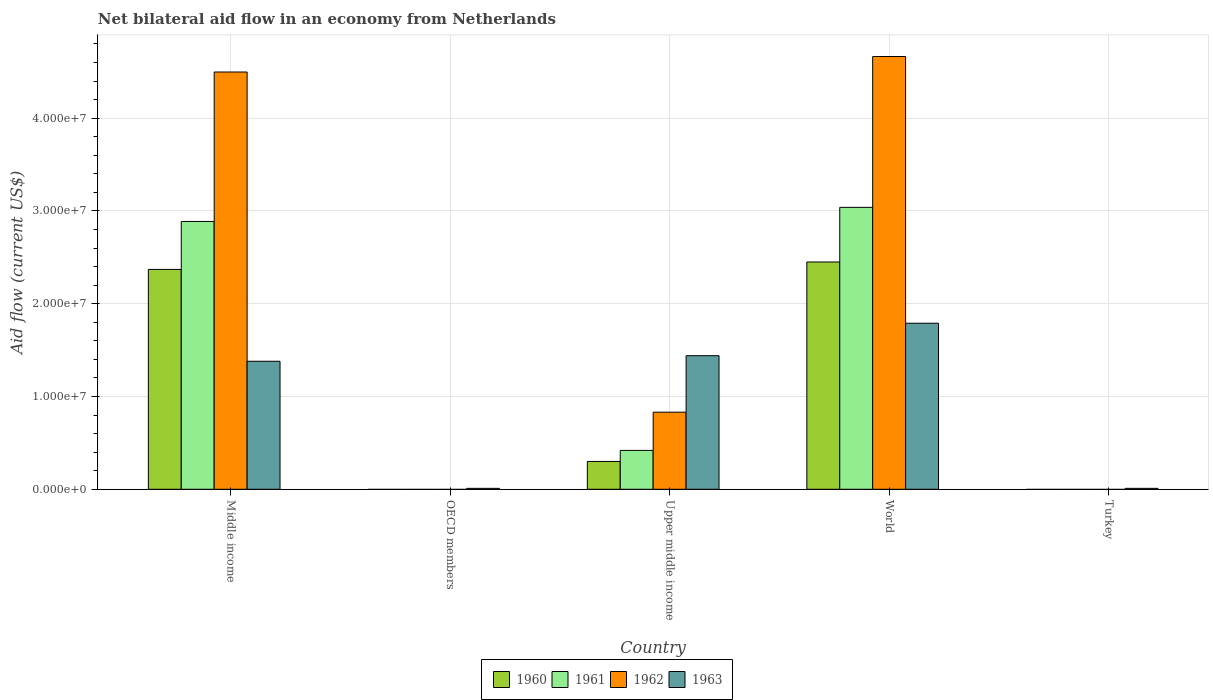Are the number of bars per tick equal to the number of legend labels?
Offer a terse response. No. Are the number of bars on each tick of the X-axis equal?
Ensure brevity in your answer.  No. How many bars are there on the 2nd tick from the left?
Keep it short and to the point. 1. In how many cases, is the number of bars for a given country not equal to the number of legend labels?
Your answer should be compact. 2. Across all countries, what is the maximum net bilateral aid flow in 1963?
Keep it short and to the point. 1.79e+07. Across all countries, what is the minimum net bilateral aid flow in 1963?
Offer a very short reply. 1.00e+05. What is the total net bilateral aid flow in 1962 in the graph?
Give a very brief answer. 9.99e+07. What is the difference between the net bilateral aid flow in 1963 in OECD members and that in Upper middle income?
Keep it short and to the point. -1.43e+07. What is the difference between the net bilateral aid flow in 1962 in Upper middle income and the net bilateral aid flow in 1961 in Turkey?
Offer a terse response. 8.31e+06. What is the average net bilateral aid flow in 1962 per country?
Keep it short and to the point. 2.00e+07. What is the difference between the net bilateral aid flow of/in 1960 and net bilateral aid flow of/in 1961 in Upper middle income?
Provide a succinct answer. -1.19e+06. What is the ratio of the net bilateral aid flow in 1960 in Middle income to that in Upper middle income?
Your answer should be very brief. 7.9. Is the net bilateral aid flow in 1963 in Upper middle income less than that in World?
Keep it short and to the point. Yes. What is the difference between the highest and the second highest net bilateral aid flow in 1962?
Your answer should be very brief. 1.67e+06. What is the difference between the highest and the lowest net bilateral aid flow in 1963?
Make the answer very short. 1.78e+07. In how many countries, is the net bilateral aid flow in 1961 greater than the average net bilateral aid flow in 1961 taken over all countries?
Give a very brief answer. 2. Is the sum of the net bilateral aid flow in 1960 in Middle income and World greater than the maximum net bilateral aid flow in 1963 across all countries?
Give a very brief answer. Yes. Is it the case that in every country, the sum of the net bilateral aid flow in 1960 and net bilateral aid flow in 1962 is greater than the sum of net bilateral aid flow in 1961 and net bilateral aid flow in 1963?
Ensure brevity in your answer.  No. Is it the case that in every country, the sum of the net bilateral aid flow in 1962 and net bilateral aid flow in 1963 is greater than the net bilateral aid flow in 1961?
Your response must be concise. Yes. How many bars are there?
Keep it short and to the point. 14. Are all the bars in the graph horizontal?
Your answer should be very brief. No. Does the graph contain any zero values?
Keep it short and to the point. Yes. Where does the legend appear in the graph?
Make the answer very short. Bottom center. How are the legend labels stacked?
Provide a succinct answer. Horizontal. What is the title of the graph?
Make the answer very short. Net bilateral aid flow in an economy from Netherlands. Does "1987" appear as one of the legend labels in the graph?
Provide a short and direct response. No. What is the label or title of the X-axis?
Offer a very short reply. Country. What is the label or title of the Y-axis?
Your response must be concise. Aid flow (current US$). What is the Aid flow (current US$) of 1960 in Middle income?
Your answer should be compact. 2.37e+07. What is the Aid flow (current US$) of 1961 in Middle income?
Make the answer very short. 2.89e+07. What is the Aid flow (current US$) of 1962 in Middle income?
Provide a short and direct response. 4.50e+07. What is the Aid flow (current US$) in 1963 in Middle income?
Your answer should be compact. 1.38e+07. What is the Aid flow (current US$) in 1960 in OECD members?
Ensure brevity in your answer.  0. What is the Aid flow (current US$) of 1961 in OECD members?
Provide a succinct answer. 0. What is the Aid flow (current US$) of 1961 in Upper middle income?
Your answer should be very brief. 4.19e+06. What is the Aid flow (current US$) of 1962 in Upper middle income?
Offer a terse response. 8.31e+06. What is the Aid flow (current US$) in 1963 in Upper middle income?
Ensure brevity in your answer.  1.44e+07. What is the Aid flow (current US$) of 1960 in World?
Make the answer very short. 2.45e+07. What is the Aid flow (current US$) in 1961 in World?
Your answer should be compact. 3.04e+07. What is the Aid flow (current US$) of 1962 in World?
Your answer should be compact. 4.66e+07. What is the Aid flow (current US$) in 1963 in World?
Your response must be concise. 1.79e+07. What is the Aid flow (current US$) in 1961 in Turkey?
Your response must be concise. 0. Across all countries, what is the maximum Aid flow (current US$) of 1960?
Keep it short and to the point. 2.45e+07. Across all countries, what is the maximum Aid flow (current US$) in 1961?
Give a very brief answer. 3.04e+07. Across all countries, what is the maximum Aid flow (current US$) of 1962?
Your answer should be compact. 4.66e+07. Across all countries, what is the maximum Aid flow (current US$) in 1963?
Keep it short and to the point. 1.79e+07. Across all countries, what is the minimum Aid flow (current US$) of 1960?
Provide a succinct answer. 0. Across all countries, what is the minimum Aid flow (current US$) of 1963?
Make the answer very short. 1.00e+05. What is the total Aid flow (current US$) in 1960 in the graph?
Give a very brief answer. 5.12e+07. What is the total Aid flow (current US$) of 1961 in the graph?
Give a very brief answer. 6.34e+07. What is the total Aid flow (current US$) of 1962 in the graph?
Keep it short and to the point. 9.99e+07. What is the total Aid flow (current US$) of 1963 in the graph?
Your response must be concise. 4.63e+07. What is the difference between the Aid flow (current US$) of 1963 in Middle income and that in OECD members?
Your answer should be very brief. 1.37e+07. What is the difference between the Aid flow (current US$) in 1960 in Middle income and that in Upper middle income?
Keep it short and to the point. 2.07e+07. What is the difference between the Aid flow (current US$) of 1961 in Middle income and that in Upper middle income?
Provide a succinct answer. 2.47e+07. What is the difference between the Aid flow (current US$) in 1962 in Middle income and that in Upper middle income?
Your answer should be compact. 3.67e+07. What is the difference between the Aid flow (current US$) of 1963 in Middle income and that in Upper middle income?
Provide a succinct answer. -6.00e+05. What is the difference between the Aid flow (current US$) of 1960 in Middle income and that in World?
Give a very brief answer. -8.00e+05. What is the difference between the Aid flow (current US$) in 1961 in Middle income and that in World?
Your answer should be compact. -1.52e+06. What is the difference between the Aid flow (current US$) in 1962 in Middle income and that in World?
Provide a short and direct response. -1.67e+06. What is the difference between the Aid flow (current US$) of 1963 in Middle income and that in World?
Your response must be concise. -4.10e+06. What is the difference between the Aid flow (current US$) in 1963 in Middle income and that in Turkey?
Ensure brevity in your answer.  1.37e+07. What is the difference between the Aid flow (current US$) of 1963 in OECD members and that in Upper middle income?
Your answer should be very brief. -1.43e+07. What is the difference between the Aid flow (current US$) in 1963 in OECD members and that in World?
Make the answer very short. -1.78e+07. What is the difference between the Aid flow (current US$) in 1960 in Upper middle income and that in World?
Offer a terse response. -2.15e+07. What is the difference between the Aid flow (current US$) in 1961 in Upper middle income and that in World?
Offer a very short reply. -2.62e+07. What is the difference between the Aid flow (current US$) of 1962 in Upper middle income and that in World?
Offer a terse response. -3.83e+07. What is the difference between the Aid flow (current US$) of 1963 in Upper middle income and that in World?
Offer a terse response. -3.50e+06. What is the difference between the Aid flow (current US$) of 1963 in Upper middle income and that in Turkey?
Keep it short and to the point. 1.43e+07. What is the difference between the Aid flow (current US$) in 1963 in World and that in Turkey?
Keep it short and to the point. 1.78e+07. What is the difference between the Aid flow (current US$) in 1960 in Middle income and the Aid flow (current US$) in 1963 in OECD members?
Your answer should be very brief. 2.36e+07. What is the difference between the Aid flow (current US$) of 1961 in Middle income and the Aid flow (current US$) of 1963 in OECD members?
Provide a short and direct response. 2.88e+07. What is the difference between the Aid flow (current US$) in 1962 in Middle income and the Aid flow (current US$) in 1963 in OECD members?
Your answer should be compact. 4.49e+07. What is the difference between the Aid flow (current US$) of 1960 in Middle income and the Aid flow (current US$) of 1961 in Upper middle income?
Offer a terse response. 1.95e+07. What is the difference between the Aid flow (current US$) in 1960 in Middle income and the Aid flow (current US$) in 1962 in Upper middle income?
Your answer should be compact. 1.54e+07. What is the difference between the Aid flow (current US$) in 1960 in Middle income and the Aid flow (current US$) in 1963 in Upper middle income?
Provide a short and direct response. 9.30e+06. What is the difference between the Aid flow (current US$) in 1961 in Middle income and the Aid flow (current US$) in 1962 in Upper middle income?
Make the answer very short. 2.06e+07. What is the difference between the Aid flow (current US$) of 1961 in Middle income and the Aid flow (current US$) of 1963 in Upper middle income?
Your answer should be compact. 1.45e+07. What is the difference between the Aid flow (current US$) in 1962 in Middle income and the Aid flow (current US$) in 1963 in Upper middle income?
Provide a succinct answer. 3.06e+07. What is the difference between the Aid flow (current US$) in 1960 in Middle income and the Aid flow (current US$) in 1961 in World?
Your answer should be compact. -6.69e+06. What is the difference between the Aid flow (current US$) in 1960 in Middle income and the Aid flow (current US$) in 1962 in World?
Your answer should be very brief. -2.30e+07. What is the difference between the Aid flow (current US$) of 1960 in Middle income and the Aid flow (current US$) of 1963 in World?
Provide a short and direct response. 5.80e+06. What is the difference between the Aid flow (current US$) in 1961 in Middle income and the Aid flow (current US$) in 1962 in World?
Give a very brief answer. -1.78e+07. What is the difference between the Aid flow (current US$) in 1961 in Middle income and the Aid flow (current US$) in 1963 in World?
Offer a terse response. 1.10e+07. What is the difference between the Aid flow (current US$) of 1962 in Middle income and the Aid flow (current US$) of 1963 in World?
Your answer should be compact. 2.71e+07. What is the difference between the Aid flow (current US$) of 1960 in Middle income and the Aid flow (current US$) of 1963 in Turkey?
Your answer should be very brief. 2.36e+07. What is the difference between the Aid flow (current US$) in 1961 in Middle income and the Aid flow (current US$) in 1963 in Turkey?
Ensure brevity in your answer.  2.88e+07. What is the difference between the Aid flow (current US$) of 1962 in Middle income and the Aid flow (current US$) of 1963 in Turkey?
Ensure brevity in your answer.  4.49e+07. What is the difference between the Aid flow (current US$) in 1960 in Upper middle income and the Aid flow (current US$) in 1961 in World?
Offer a very short reply. -2.74e+07. What is the difference between the Aid flow (current US$) in 1960 in Upper middle income and the Aid flow (current US$) in 1962 in World?
Your response must be concise. -4.36e+07. What is the difference between the Aid flow (current US$) of 1960 in Upper middle income and the Aid flow (current US$) of 1963 in World?
Offer a very short reply. -1.49e+07. What is the difference between the Aid flow (current US$) in 1961 in Upper middle income and the Aid flow (current US$) in 1962 in World?
Your answer should be compact. -4.25e+07. What is the difference between the Aid flow (current US$) of 1961 in Upper middle income and the Aid flow (current US$) of 1963 in World?
Your answer should be very brief. -1.37e+07. What is the difference between the Aid flow (current US$) in 1962 in Upper middle income and the Aid flow (current US$) in 1963 in World?
Offer a terse response. -9.59e+06. What is the difference between the Aid flow (current US$) of 1960 in Upper middle income and the Aid flow (current US$) of 1963 in Turkey?
Your response must be concise. 2.90e+06. What is the difference between the Aid flow (current US$) in 1961 in Upper middle income and the Aid flow (current US$) in 1963 in Turkey?
Your answer should be very brief. 4.09e+06. What is the difference between the Aid flow (current US$) in 1962 in Upper middle income and the Aid flow (current US$) in 1963 in Turkey?
Your answer should be compact. 8.21e+06. What is the difference between the Aid flow (current US$) in 1960 in World and the Aid flow (current US$) in 1963 in Turkey?
Your answer should be compact. 2.44e+07. What is the difference between the Aid flow (current US$) in 1961 in World and the Aid flow (current US$) in 1963 in Turkey?
Keep it short and to the point. 3.03e+07. What is the difference between the Aid flow (current US$) of 1962 in World and the Aid flow (current US$) of 1963 in Turkey?
Provide a short and direct response. 4.66e+07. What is the average Aid flow (current US$) of 1960 per country?
Provide a succinct answer. 1.02e+07. What is the average Aid flow (current US$) in 1961 per country?
Your answer should be very brief. 1.27e+07. What is the average Aid flow (current US$) in 1962 per country?
Give a very brief answer. 2.00e+07. What is the average Aid flow (current US$) of 1963 per country?
Provide a short and direct response. 9.26e+06. What is the difference between the Aid flow (current US$) of 1960 and Aid flow (current US$) of 1961 in Middle income?
Ensure brevity in your answer.  -5.17e+06. What is the difference between the Aid flow (current US$) of 1960 and Aid flow (current US$) of 1962 in Middle income?
Offer a terse response. -2.13e+07. What is the difference between the Aid flow (current US$) in 1960 and Aid flow (current US$) in 1963 in Middle income?
Your response must be concise. 9.90e+06. What is the difference between the Aid flow (current US$) of 1961 and Aid flow (current US$) of 1962 in Middle income?
Provide a short and direct response. -1.61e+07. What is the difference between the Aid flow (current US$) of 1961 and Aid flow (current US$) of 1963 in Middle income?
Your answer should be very brief. 1.51e+07. What is the difference between the Aid flow (current US$) in 1962 and Aid flow (current US$) in 1963 in Middle income?
Your answer should be compact. 3.12e+07. What is the difference between the Aid flow (current US$) in 1960 and Aid flow (current US$) in 1961 in Upper middle income?
Your response must be concise. -1.19e+06. What is the difference between the Aid flow (current US$) in 1960 and Aid flow (current US$) in 1962 in Upper middle income?
Offer a terse response. -5.31e+06. What is the difference between the Aid flow (current US$) of 1960 and Aid flow (current US$) of 1963 in Upper middle income?
Provide a succinct answer. -1.14e+07. What is the difference between the Aid flow (current US$) of 1961 and Aid flow (current US$) of 1962 in Upper middle income?
Offer a terse response. -4.12e+06. What is the difference between the Aid flow (current US$) of 1961 and Aid flow (current US$) of 1963 in Upper middle income?
Your response must be concise. -1.02e+07. What is the difference between the Aid flow (current US$) of 1962 and Aid flow (current US$) of 1963 in Upper middle income?
Give a very brief answer. -6.09e+06. What is the difference between the Aid flow (current US$) of 1960 and Aid flow (current US$) of 1961 in World?
Your answer should be very brief. -5.89e+06. What is the difference between the Aid flow (current US$) of 1960 and Aid flow (current US$) of 1962 in World?
Your answer should be very brief. -2.22e+07. What is the difference between the Aid flow (current US$) in 1960 and Aid flow (current US$) in 1963 in World?
Your response must be concise. 6.60e+06. What is the difference between the Aid flow (current US$) of 1961 and Aid flow (current US$) of 1962 in World?
Your answer should be very brief. -1.63e+07. What is the difference between the Aid flow (current US$) in 1961 and Aid flow (current US$) in 1963 in World?
Your answer should be compact. 1.25e+07. What is the difference between the Aid flow (current US$) of 1962 and Aid flow (current US$) of 1963 in World?
Offer a terse response. 2.88e+07. What is the ratio of the Aid flow (current US$) of 1963 in Middle income to that in OECD members?
Offer a terse response. 138. What is the ratio of the Aid flow (current US$) of 1961 in Middle income to that in Upper middle income?
Keep it short and to the point. 6.89. What is the ratio of the Aid flow (current US$) in 1962 in Middle income to that in Upper middle income?
Give a very brief answer. 5.41. What is the ratio of the Aid flow (current US$) in 1960 in Middle income to that in World?
Provide a short and direct response. 0.97. What is the ratio of the Aid flow (current US$) in 1962 in Middle income to that in World?
Ensure brevity in your answer.  0.96. What is the ratio of the Aid flow (current US$) in 1963 in Middle income to that in World?
Your answer should be compact. 0.77. What is the ratio of the Aid flow (current US$) of 1963 in Middle income to that in Turkey?
Provide a short and direct response. 138. What is the ratio of the Aid flow (current US$) of 1963 in OECD members to that in Upper middle income?
Keep it short and to the point. 0.01. What is the ratio of the Aid flow (current US$) in 1963 in OECD members to that in World?
Your answer should be compact. 0.01. What is the ratio of the Aid flow (current US$) of 1960 in Upper middle income to that in World?
Your answer should be very brief. 0.12. What is the ratio of the Aid flow (current US$) of 1961 in Upper middle income to that in World?
Your answer should be very brief. 0.14. What is the ratio of the Aid flow (current US$) of 1962 in Upper middle income to that in World?
Offer a very short reply. 0.18. What is the ratio of the Aid flow (current US$) in 1963 in Upper middle income to that in World?
Offer a terse response. 0.8. What is the ratio of the Aid flow (current US$) in 1963 in Upper middle income to that in Turkey?
Offer a very short reply. 144. What is the ratio of the Aid flow (current US$) of 1963 in World to that in Turkey?
Keep it short and to the point. 179. What is the difference between the highest and the second highest Aid flow (current US$) of 1961?
Your answer should be very brief. 1.52e+06. What is the difference between the highest and the second highest Aid flow (current US$) in 1962?
Provide a short and direct response. 1.67e+06. What is the difference between the highest and the second highest Aid flow (current US$) of 1963?
Keep it short and to the point. 3.50e+06. What is the difference between the highest and the lowest Aid flow (current US$) of 1960?
Your answer should be very brief. 2.45e+07. What is the difference between the highest and the lowest Aid flow (current US$) in 1961?
Offer a very short reply. 3.04e+07. What is the difference between the highest and the lowest Aid flow (current US$) in 1962?
Your response must be concise. 4.66e+07. What is the difference between the highest and the lowest Aid flow (current US$) of 1963?
Your answer should be very brief. 1.78e+07. 